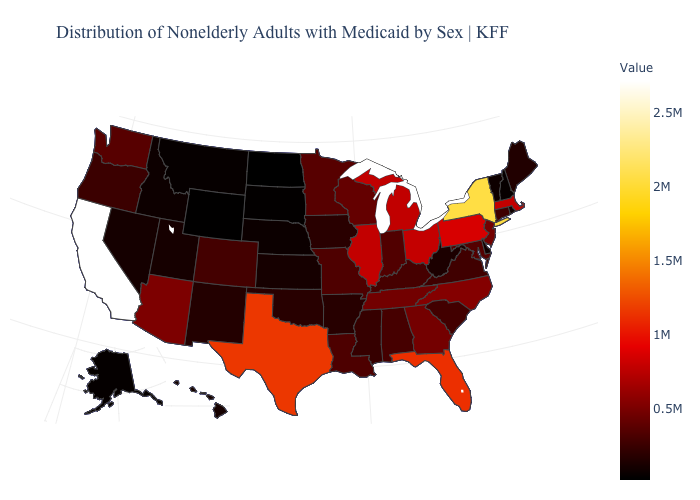Is the legend a continuous bar?
Keep it brief. Yes. Among the states that border West Virginia , which have the lowest value?
Concise answer only. Virginia. Which states have the lowest value in the West?
Short answer required. Wyoming. Among the states that border Georgia , does Tennessee have the highest value?
Short answer required. No. Does Vermont have a higher value than New York?
Be succinct. No. Does California have a higher value than Colorado?
Be succinct. Yes. 